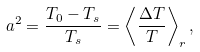<formula> <loc_0><loc_0><loc_500><loc_500>a ^ { 2 } = \frac { T _ { 0 } - T _ { s } } { T _ { s } } = \left < \frac { \Delta T } { T } \right > _ { r } ,</formula> 